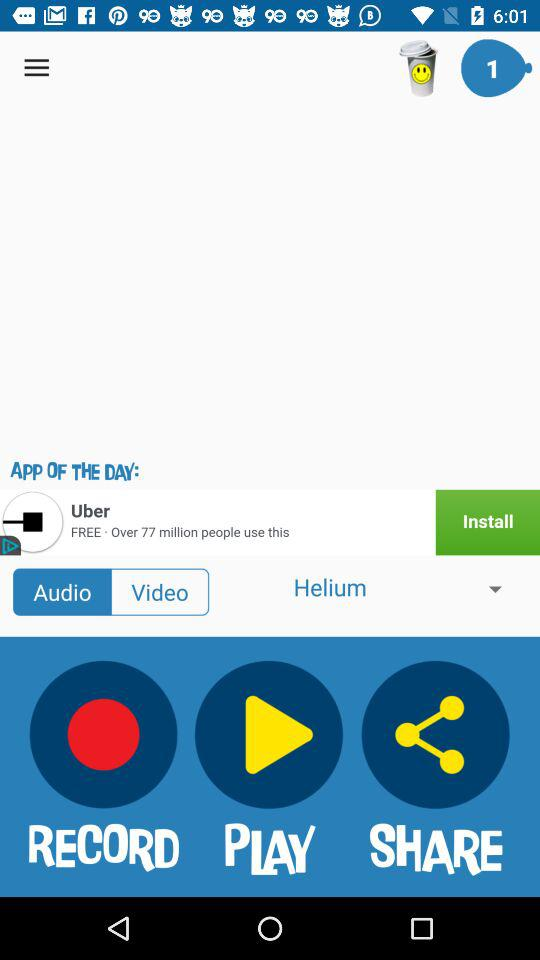Which option has been selected? The selected options are "Audio" and "Helium". 